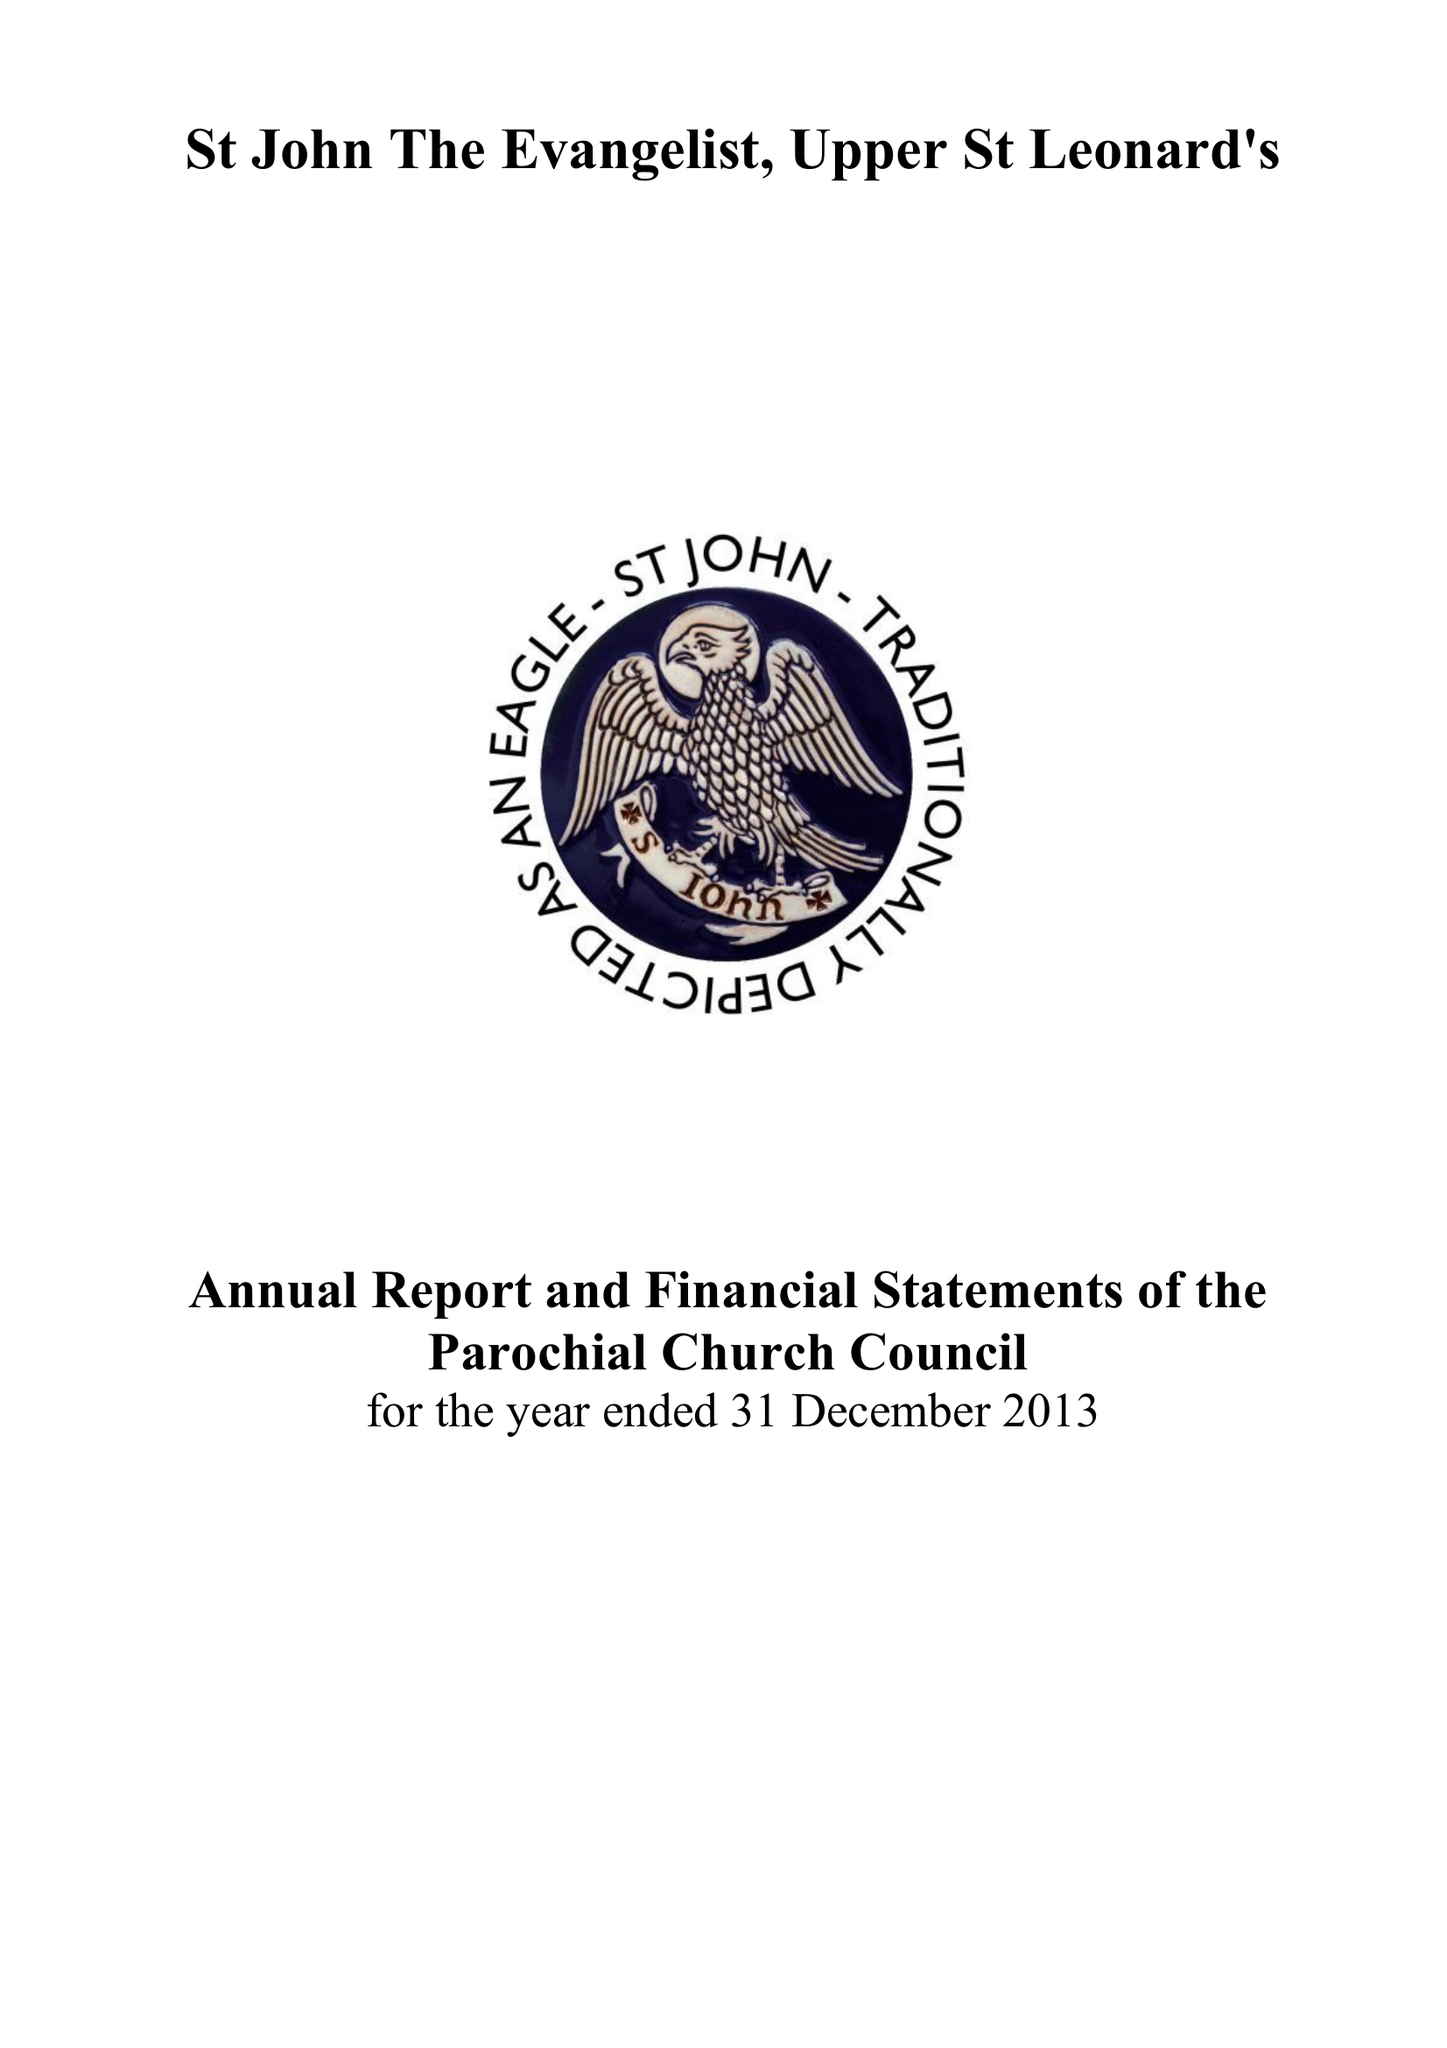What is the value for the income_annually_in_british_pounds?
Answer the question using a single word or phrase. 118300.00 